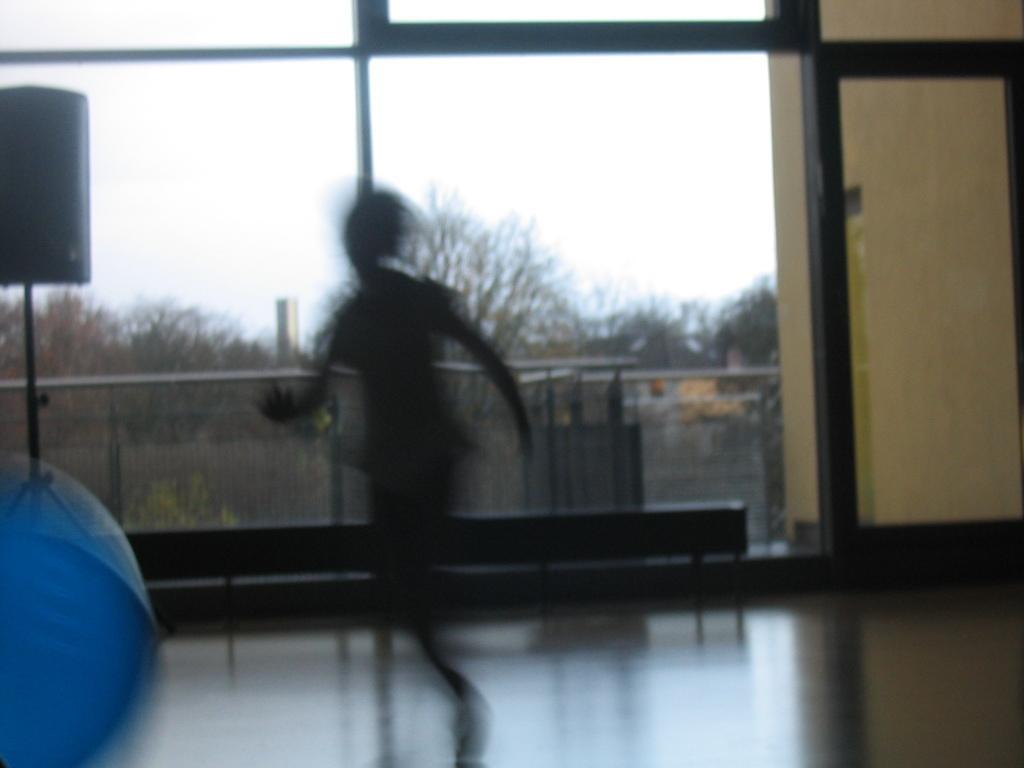Please provide a concise description of this image. In this picture there is a person who is running on the floor. In the background I can see the trees, plants, buildings and other objects. At the top I can see the sky and clouds. On the left there is a lamp which is placed near to the table and fencing. 